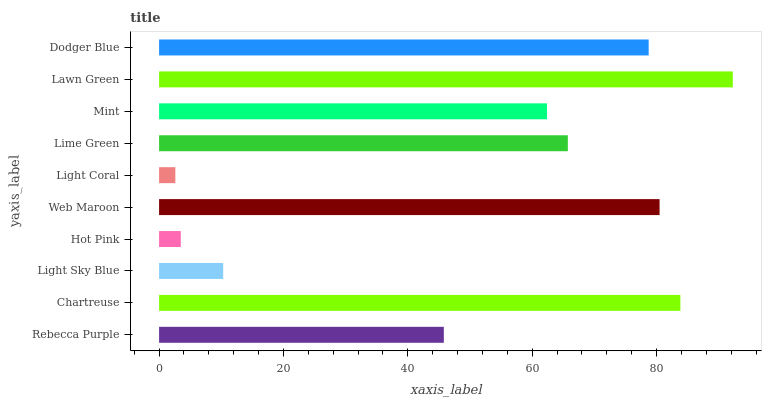Is Light Coral the minimum?
Answer yes or no. Yes. Is Lawn Green the maximum?
Answer yes or no. Yes. Is Chartreuse the minimum?
Answer yes or no. No. Is Chartreuse the maximum?
Answer yes or no. No. Is Chartreuse greater than Rebecca Purple?
Answer yes or no. Yes. Is Rebecca Purple less than Chartreuse?
Answer yes or no. Yes. Is Rebecca Purple greater than Chartreuse?
Answer yes or no. No. Is Chartreuse less than Rebecca Purple?
Answer yes or no. No. Is Lime Green the high median?
Answer yes or no. Yes. Is Mint the low median?
Answer yes or no. Yes. Is Dodger Blue the high median?
Answer yes or no. No. Is Light Sky Blue the low median?
Answer yes or no. No. 